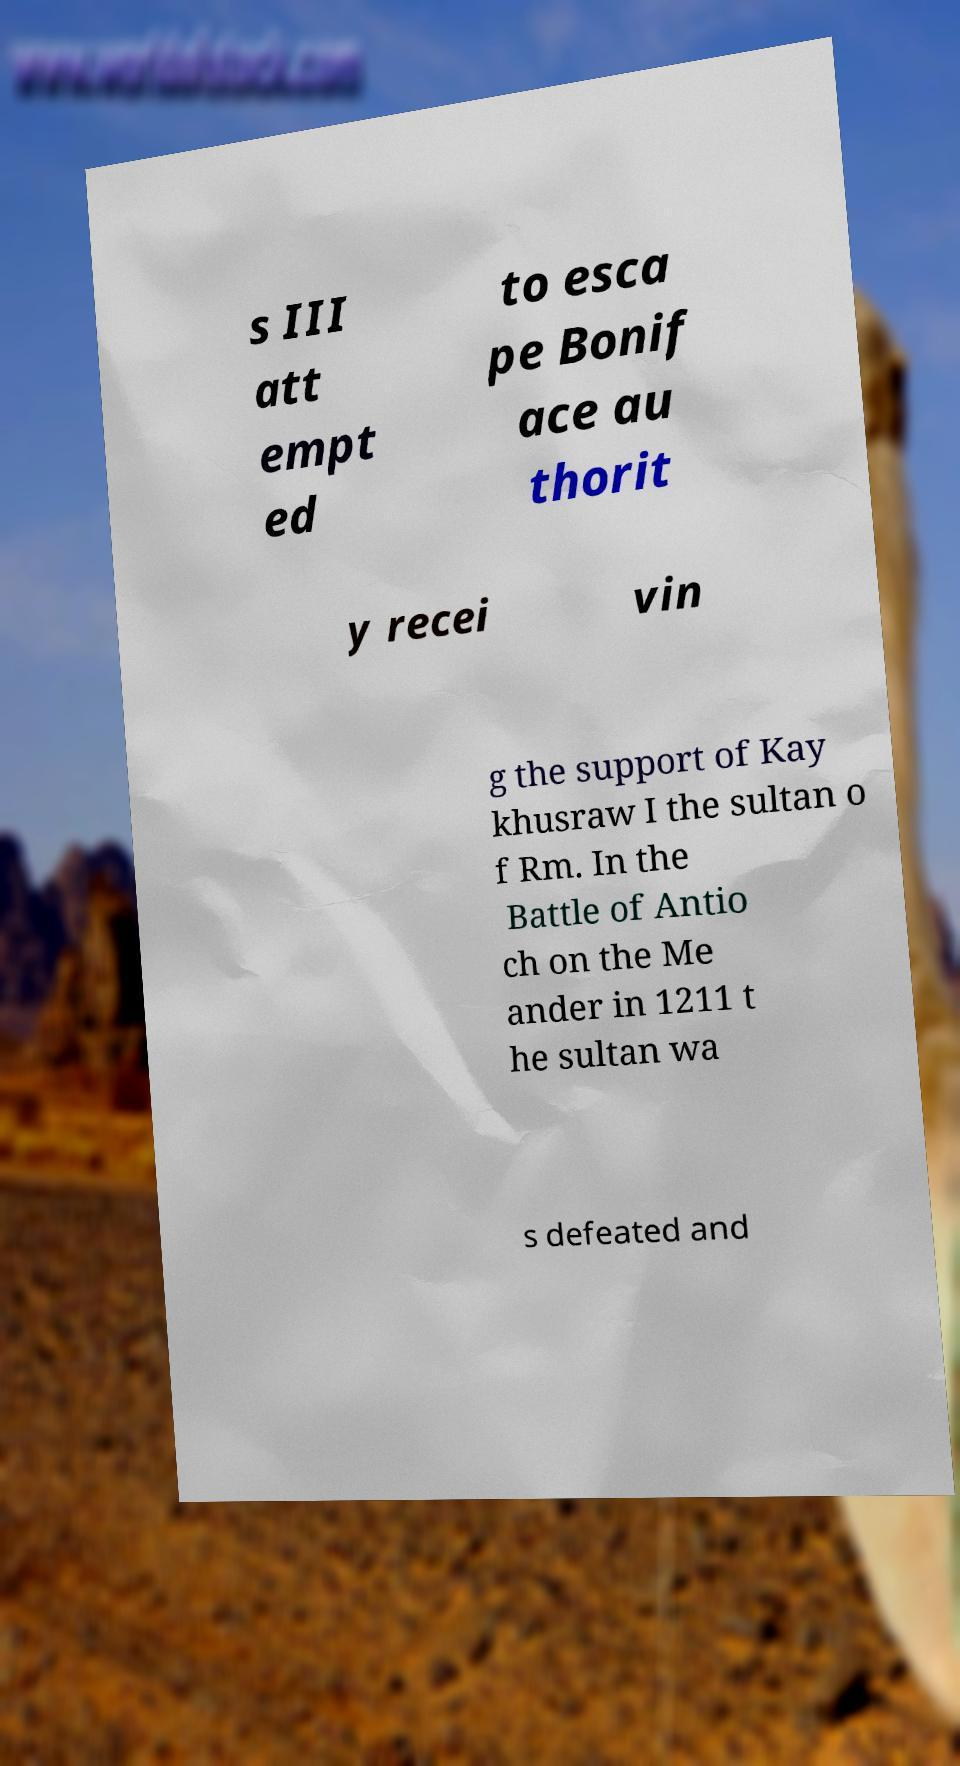Can you accurately transcribe the text from the provided image for me? s III att empt ed to esca pe Bonif ace au thorit y recei vin g the support of Kay khusraw I the sultan o f Rm. In the Battle of Antio ch on the Me ander in 1211 t he sultan wa s defeated and 